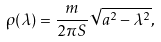Convert formula to latex. <formula><loc_0><loc_0><loc_500><loc_500>\rho ( \lambda ) = \frac { m } { 2 \pi S } \sqrt { a ^ { 2 } - \lambda ^ { 2 } } ,</formula> 